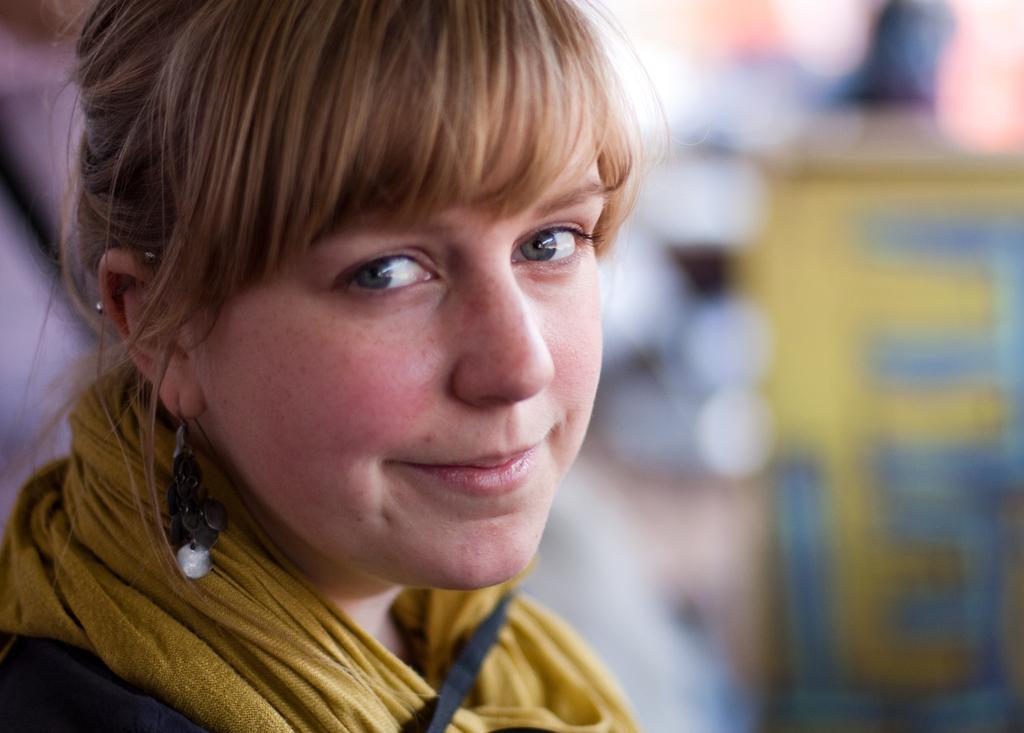Could you give a brief overview of what you see in this image? Here a woman is looking at this side, she wore ear rings. Her hair is in brown color. 